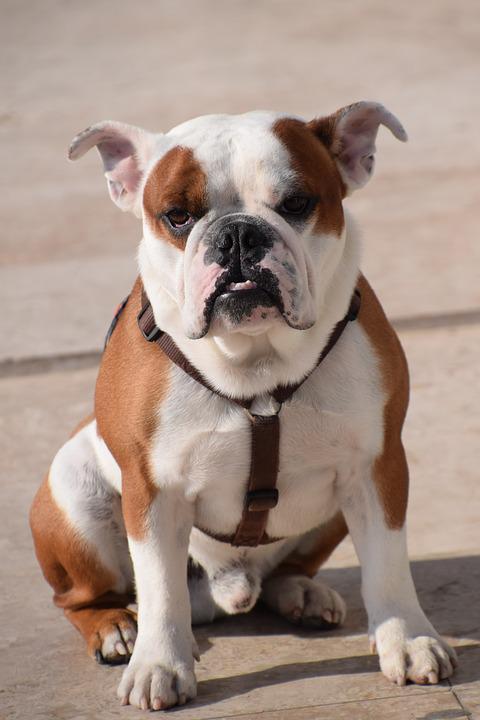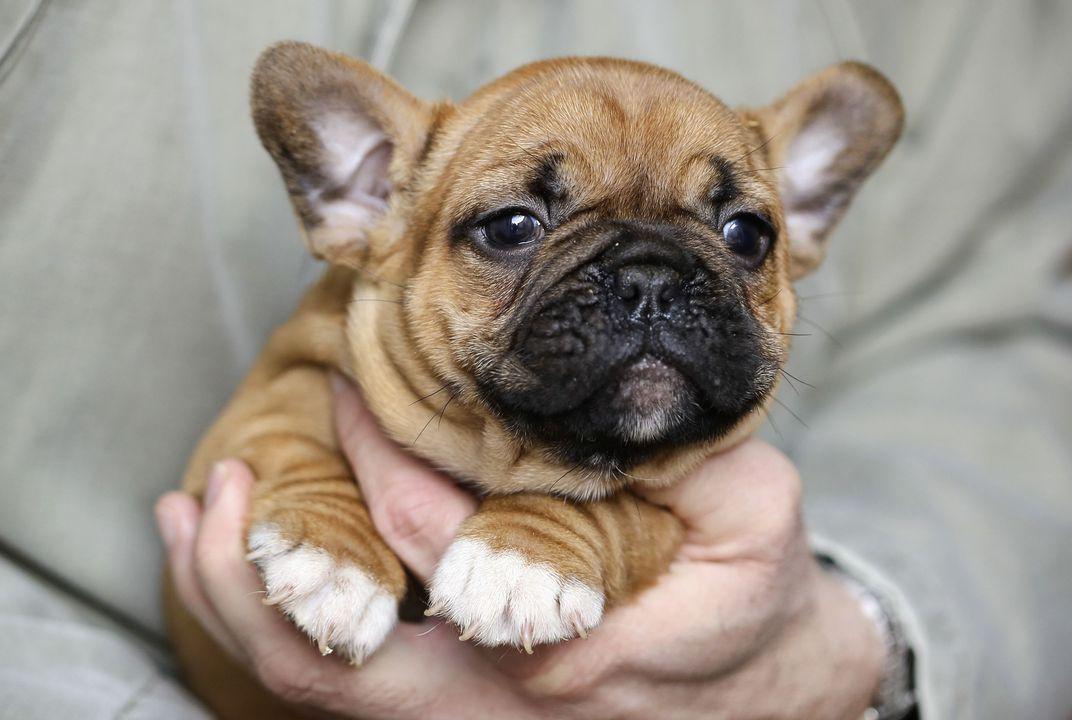The first image is the image on the left, the second image is the image on the right. For the images shown, is this caption "Each image shows one dog standing on all fours, and one image shows a dog standing with its body in profile." true? Answer yes or no. No. The first image is the image on the left, the second image is the image on the right. Considering the images on both sides, is "One dog is wearing something around his neck." valid? Answer yes or no. Yes. 